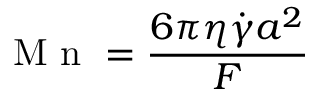<formula> <loc_0><loc_0><loc_500><loc_500>M n = \frac { 6 \pi \eta \dot { \gamma } a ^ { 2 } } { F }</formula> 